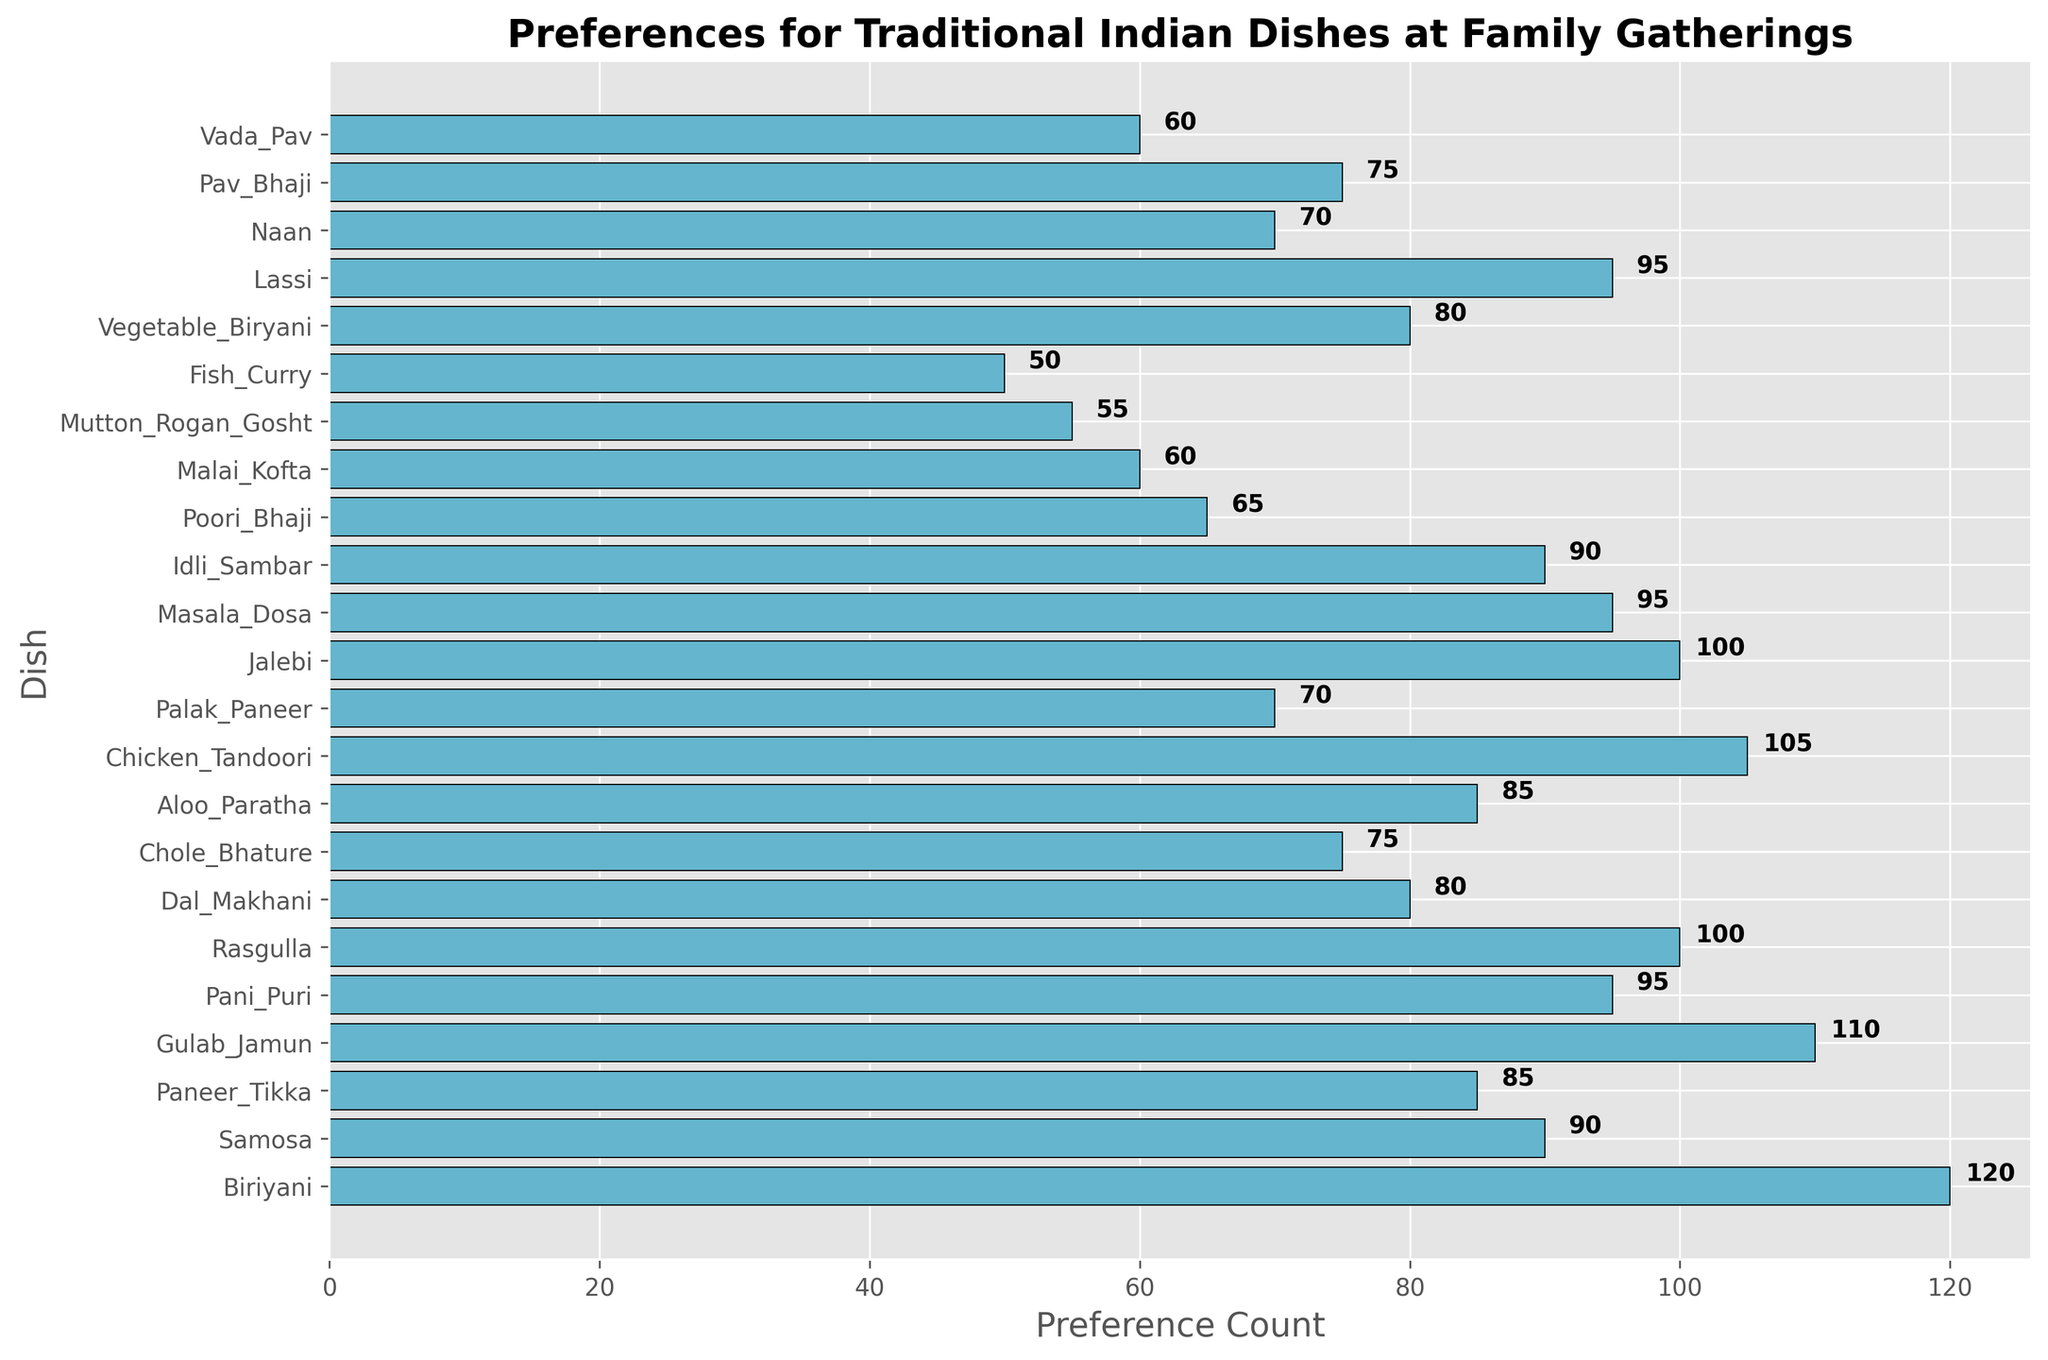Which dish has the highest preference count? Looking at the height of the bars, the tallest bar corresponds to Biriyani with a preference count of 120.
Answer: Biriyani Which dish has the lowest preference count? By observing the shortest bar, it can be seen that Fish Curry has the lowest preference count at 50.
Answer: Fish Curry How many dishes have a preference count of more than 100? By counting the bars with preference counts exceeding 100, we find Biriyani, Gulab Jamun, and Chicken Tandoori. So, there are three such dishes.
Answer: 3 What's the combined preference count for Gulab Jamun and Jalebi? The preference count for Gulab Jamun is 110 and for Jalebi is 100. Adding them together: 110 + 100 = 210.
Answer: 210 Which dishes have the same preference count? By checking the bar lengths, both Rasgulla and Jalebi have a preference count of 100.
Answer: Rasgulla, Jalebi Which dish has a slightly higher preference count: Masala Dosa or Pani Puri? By comparing the bar lengths, Masala Dosa and Pani Puri have a preference count of 95 each, making their counts equal.
Answer: Masala Dosa and Pani Puri have equal preference counts What's the preference count difference between Samosa and Idli Sambar? The preference count for Samosa is 90 and for Idli Sambar is 90. The difference is 90 - 90 = 0.
Answer: 0 What's the average preference count of the top three dishes? The preference counts of the top three dishes are Biriyani (120), Gulab Jamun (110), and Chicken Tandoori (105). Adding them together and dividing by 3: (120 + 110 + 105) / 3 = 111.67.
Answer: 111.67 Which has a higher preference count, Palak Paneer or Dal Makhani? By how much? Palak Paneer has a preference count of 70 and Dal Makhani has 80. Dal Makhani is preferred by 80 - 70 = 10 more people.
Answer: Dal Makhani by 10 Name any two dishes with a preference count below 60. From the bars, Malai Kofta (60) and Mutton Rogan Gosht (55) have preference counts below 60.
Answer: Malai Kofta, Mutton Rogan Gosht 